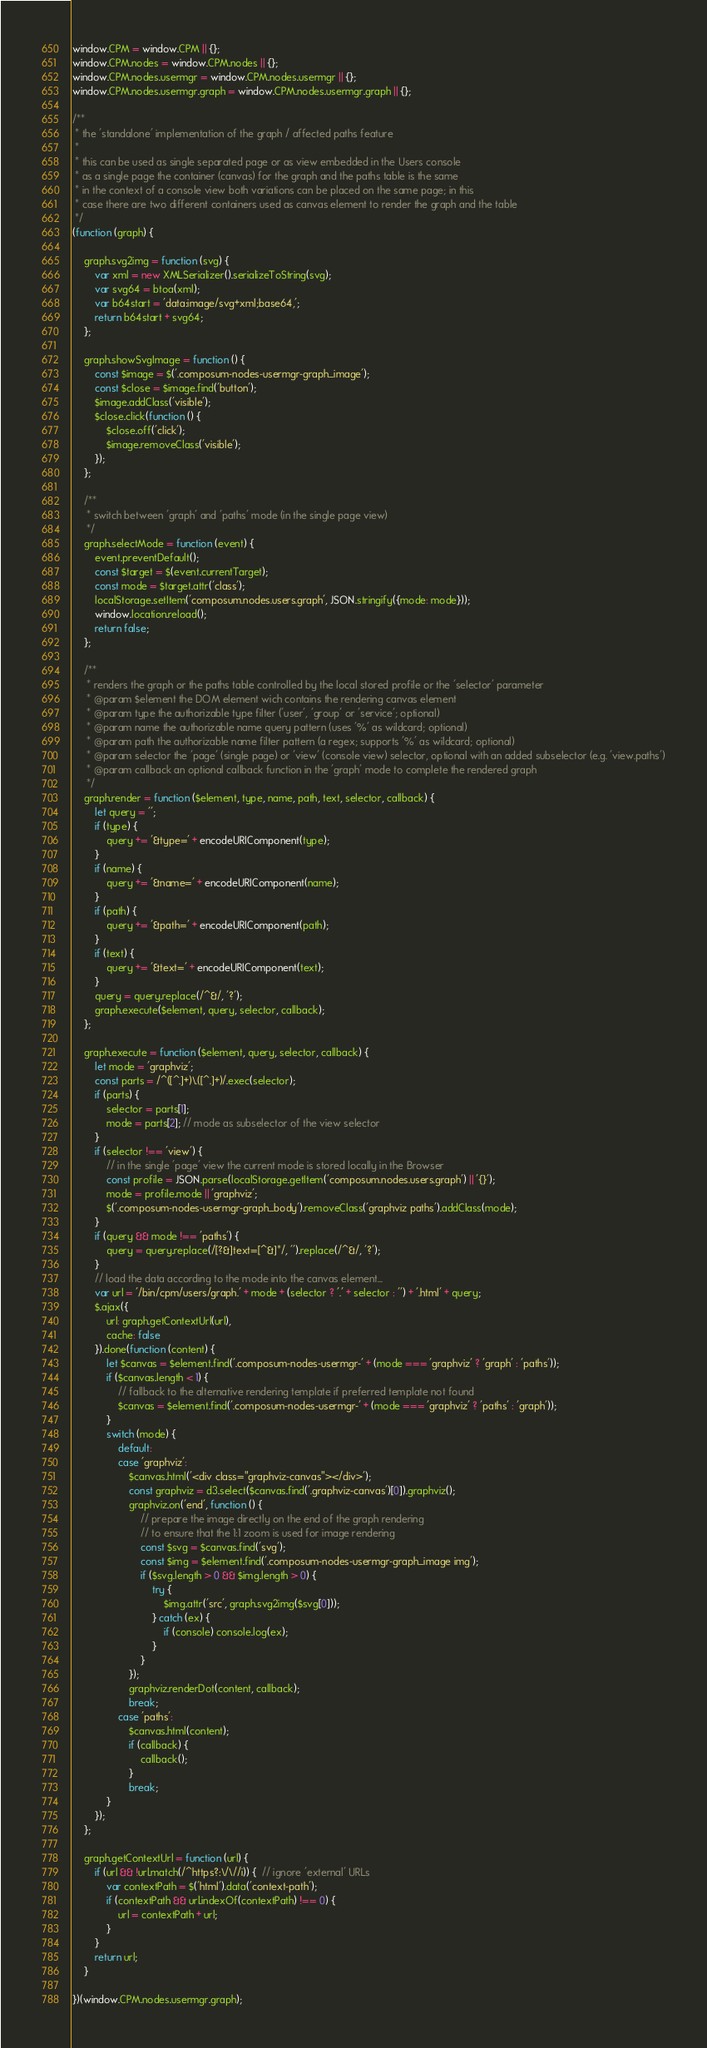<code> <loc_0><loc_0><loc_500><loc_500><_JavaScript_>window.CPM = window.CPM || {};
window.CPM.nodes = window.CPM.nodes || {};
window.CPM.nodes.usermgr = window.CPM.nodes.usermgr || {};
window.CPM.nodes.usermgr.graph = window.CPM.nodes.usermgr.graph || {};

/**
 * the 'standalone' implementation of the graph / affected paths feature
 *
 * this can be used as single separated page or as view embedded in the Users console
 * as a single page the container (canvas) for the graph and the paths table is the same
 * in the context of a console view both variations can be placed on the same page; in this
 * case there are two different containers used as canvas element to render the graph and the table
 */
(function (graph) {

    graph.svg2img = function (svg) {
        var xml = new XMLSerializer().serializeToString(svg);
        var svg64 = btoa(xml);
        var b64start = 'data:image/svg+xml;base64,';
        return b64start + svg64;
    };

    graph.showSvgImage = function () {
        const $image = $('.composum-nodes-usermgr-graph_image');
        const $close = $image.find('button');
        $image.addClass('visible');
        $close.click(function () {
            $close.off('click');
            $image.removeClass('visible');
        });
    };

    /**
     * switch between 'graph' and 'paths' mode (in the single page view)
     */
    graph.selectMode = function (event) {
        event.preventDefault();
        const $target = $(event.currentTarget);
        const mode = $target.attr('class');
        localStorage.setItem('composum.nodes.users.graph', JSON.stringify({mode: mode}));
        window.location.reload();
        return false;
    };

    /**
     * renders the graph or the paths table controlled by the local stored profile or the 'selector' parameter
     * @param $element the DOM element wich contains the rendering canvas element
     * @param type the authorizable type filter ('user', 'group' or 'service'; optional)
     * @param name the authorizable name query pattern (uses '%' as wildcard; optional)
     * @param path the authorizable name filter pattern (a regex; supports '%' as wildcard; optional)
     * @param selector the 'page' (single page) or 'view' (console view) selector, optional with an added subselector (e.g. 'view.paths')
     * @param callback an optional callback function in the 'graph' mode to complete the rendered graph
     */
    graph.render = function ($element, type, name, path, text, selector, callback) {
        let query = '';
        if (type) {
            query += '&type=' + encodeURIComponent(type);
        }
        if (name) {
            query += '&name=' + encodeURIComponent(name);
        }
        if (path) {
            query += '&path=' + encodeURIComponent(path);
        }
        if (text) {
            query += '&text=' + encodeURIComponent(text);
        }
        query = query.replace(/^&/, '?');
        graph.execute($element, query, selector, callback);
    };

    graph.execute = function ($element, query, selector, callback) {
        let mode = 'graphviz';
        const parts = /^([^.]+)\.([^.]+)/.exec(selector);
        if (parts) {
            selector = parts[1];
            mode = parts[2]; // mode as subselector of the view selector
        }
        if (selector !== 'view') {
            // in the single 'page' view the current mode is stored locally in the Browser
            const profile = JSON.parse(localStorage.getItem('composum.nodes.users.graph') || '{}');
            mode = profile.mode || 'graphviz';
            $('.composum-nodes-usermgr-graph_body').removeClass('graphviz paths').addClass(mode);
        }
        if (query && mode !== 'paths') {
            query = query.replace(/[?&]text=[^&]*/, '').replace(/^&/, '?');
        }
        // load the data according to the mode into the canvas element...
        var url = '/bin/cpm/users/graph.' + mode + (selector ? '.' + selector : '') + '.html' + query;
        $.ajax({
            url: graph.getContextUrl(url),
            cache: false
        }).done(function (content) {
            let $canvas = $element.find('.composum-nodes-usermgr-' + (mode === 'graphviz' ? 'graph' : 'paths'));
            if ($canvas.length < 1) {
                // fallback to the alternative rendering template if preferred template not found
                $canvas = $element.find('.composum-nodes-usermgr-' + (mode === 'graphviz' ? 'paths' : 'graph'));
            }
            switch (mode) {
                default:
                case 'graphviz':
                    $canvas.html('<div class="graphviz-canvas"></div>');
                    const graphviz = d3.select($canvas.find('.graphviz-canvas')[0]).graphviz();
                    graphviz.on('end', function () {
                        // prepare the image directly on the end of the graph rendering
                        // to ensure that the 1:1 zoom is used for image rendering
                        const $svg = $canvas.find('svg');
                        const $img = $element.find('.composum-nodes-usermgr-graph_image img');
                        if ($svg.length > 0 && $img.length > 0) {
                            try {
                                $img.attr('src', graph.svg2img($svg[0]));
                            } catch (ex) {
                                if (console) console.log(ex);
                            }
                        }
                    });
                    graphviz.renderDot(content, callback);
                    break;
                case 'paths':
                    $canvas.html(content);
                    if (callback) {
                        callback();
                    }
                    break;
            }
        });
    };

    graph.getContextUrl = function (url) {
        if (url && !url.match(/^https?:\/\//i)) {  // ignore 'external' URLs
            var contextPath = $('html').data('context-path');
            if (contextPath && url.indexOf(contextPath) !== 0) {
                url = contextPath + url;
            }
        }
        return url;
    }

})(window.CPM.nodes.usermgr.graph);
</code> 